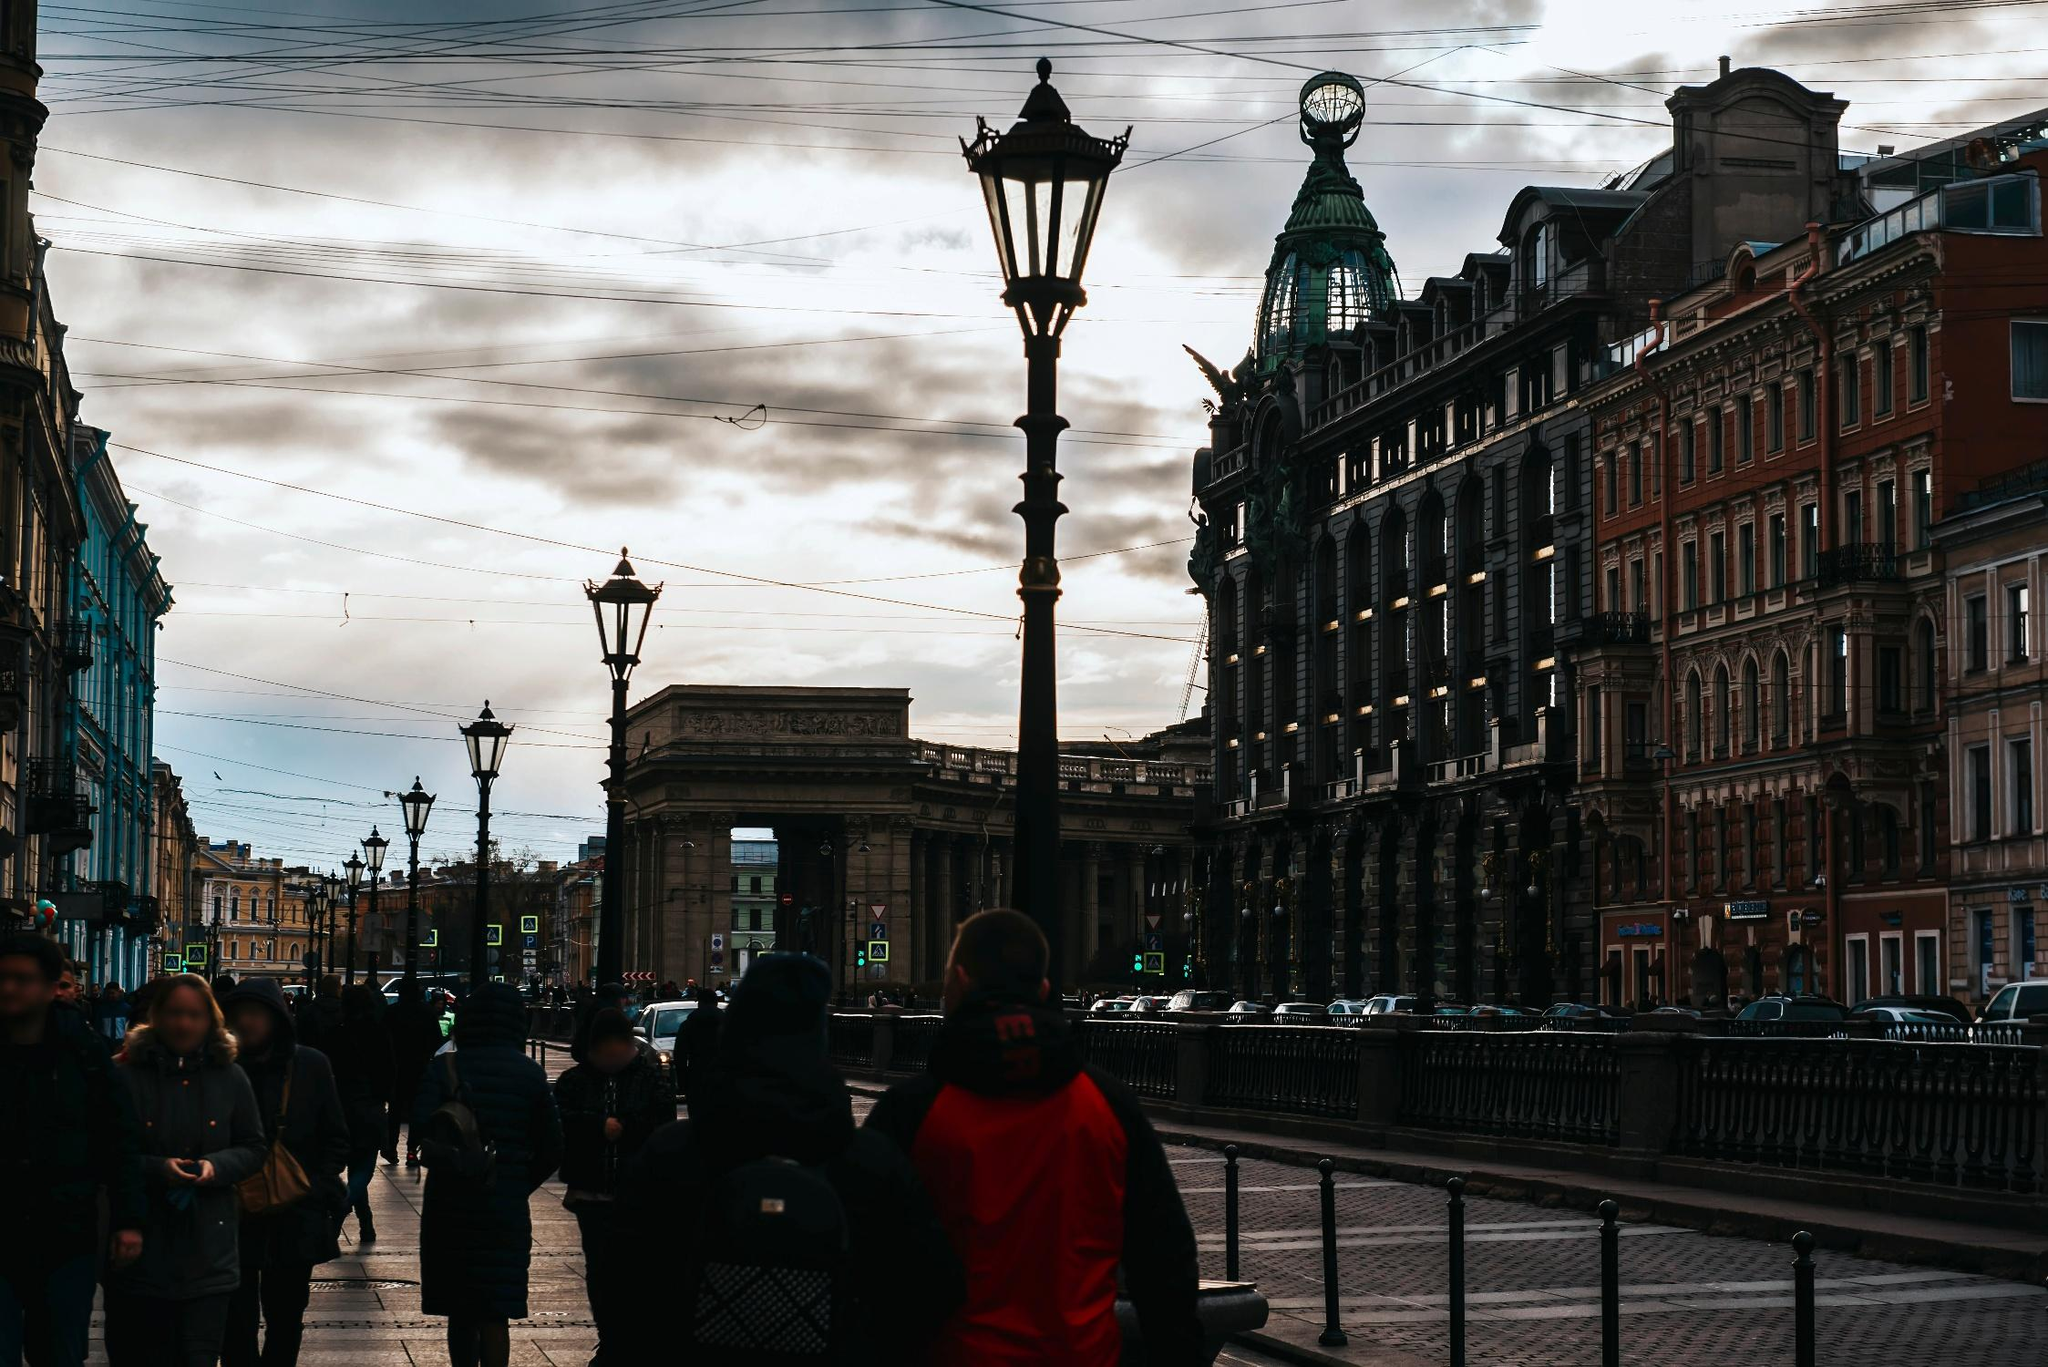What does the presence of tram lines indicate about the city’s transportation? The visible tram lines overhead suggest that the city has a well-developed, efficient public transportation network. This mode of transport is environmentally friendly and efficient in urban spaces, facilitating easy mobility for residents and reducing traffic congestion. It also indicates a historical continuity in urban planning, as many European cities have maintained and modernized their tram systems for decades. 